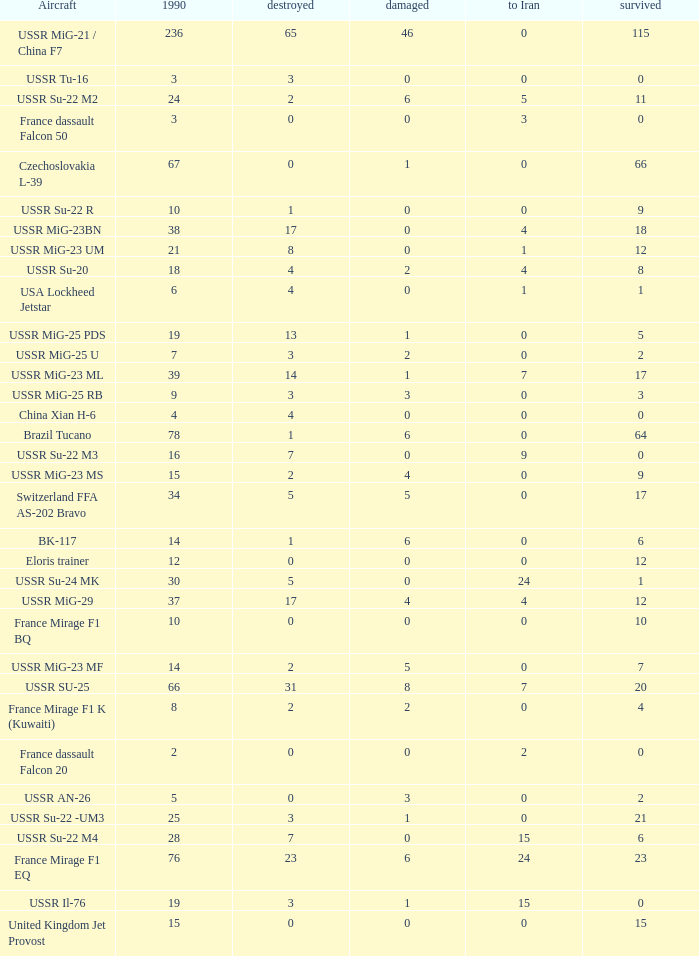If the aircraft was  ussr mig-25 rb how many were destroyed? 3.0. 